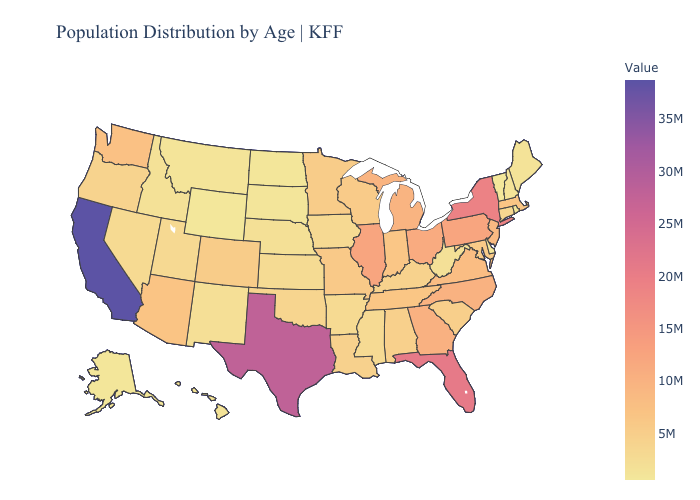Does South Carolina have the lowest value in the USA?
Short answer required. No. Does Michigan have the lowest value in the USA?
Give a very brief answer. No. Does Wyoming have the lowest value in the USA?
Keep it brief. Yes. Does Idaho have a lower value than Massachusetts?
Give a very brief answer. Yes. Is the legend a continuous bar?
Keep it brief. Yes. Does Maryland have the lowest value in the USA?
Write a very short answer. No. 